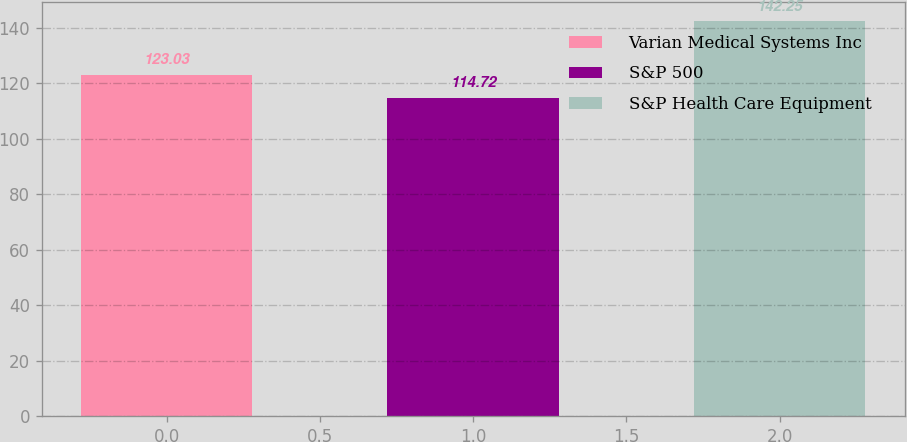Convert chart to OTSL. <chart><loc_0><loc_0><loc_500><loc_500><bar_chart><fcel>Varian Medical Systems Inc<fcel>S&P 500<fcel>S&P Health Care Equipment<nl><fcel>123.03<fcel>114.72<fcel>142.25<nl></chart> 